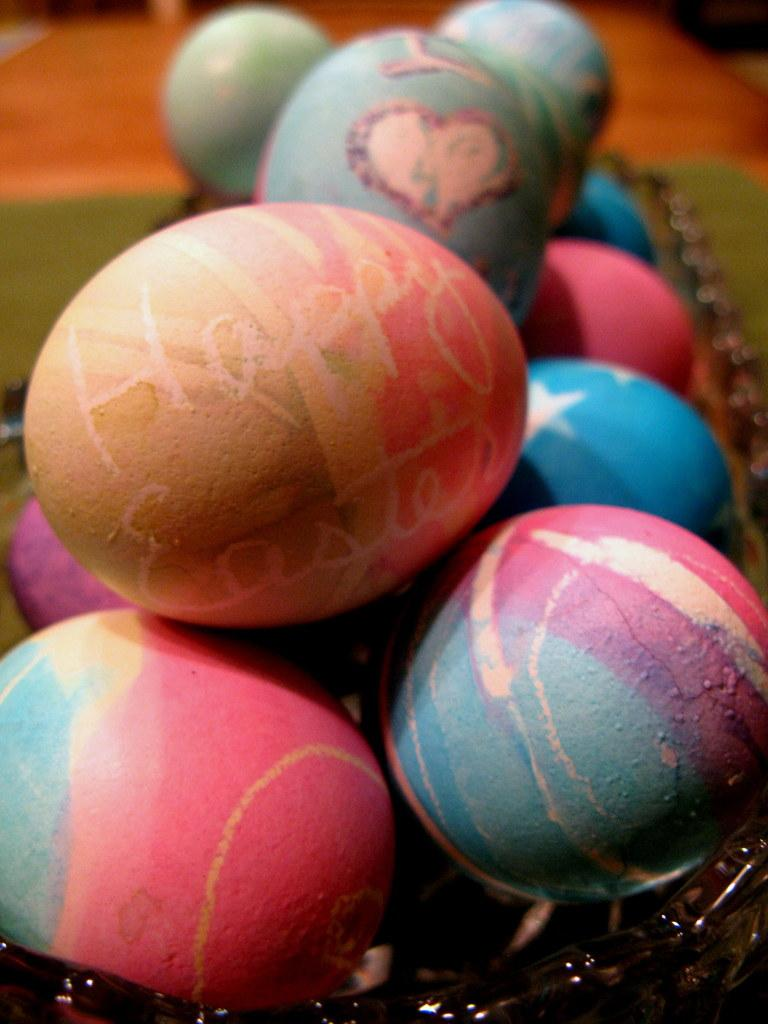What type of objects are featured in the image? There are colorful eggs in the image. Can you describe any specific details about the eggs? One of the eggs has text visible on it. How would you describe the overall appearance of the image? The background of the image is blurry. What is the topic of the discussion between the women in the image? There are no women present in the image, and therefore no discussion can be observed. 